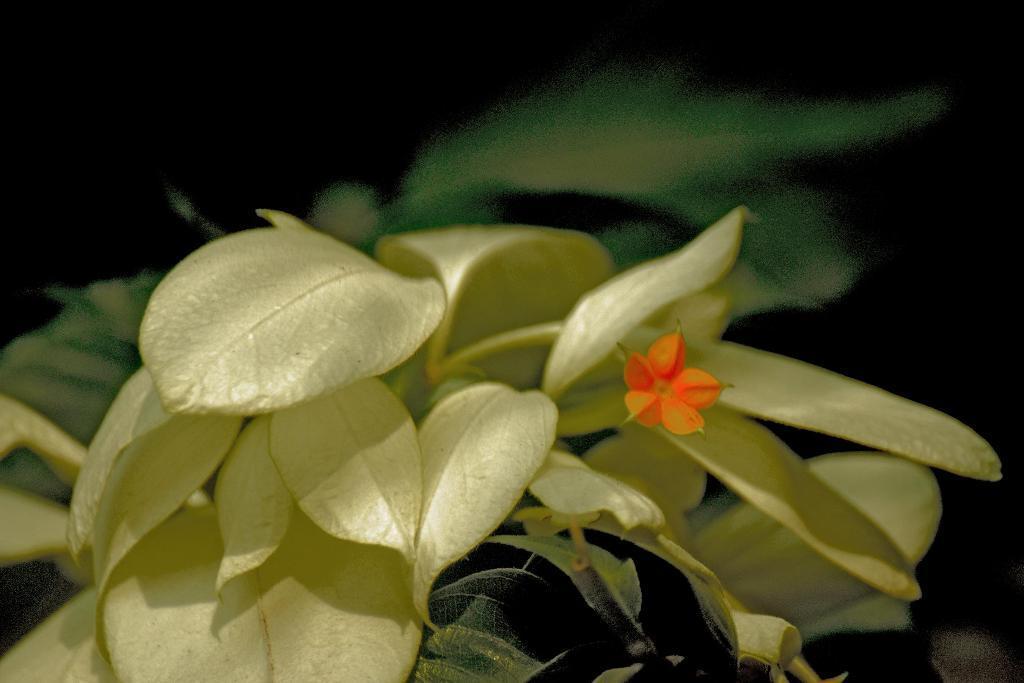In one or two sentences, can you explain what this image depicts? In this image we can see a flower, plants, also the background is dark. 